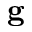Convert formula to latex. <formula><loc_0><loc_0><loc_500><loc_500>g</formula> 